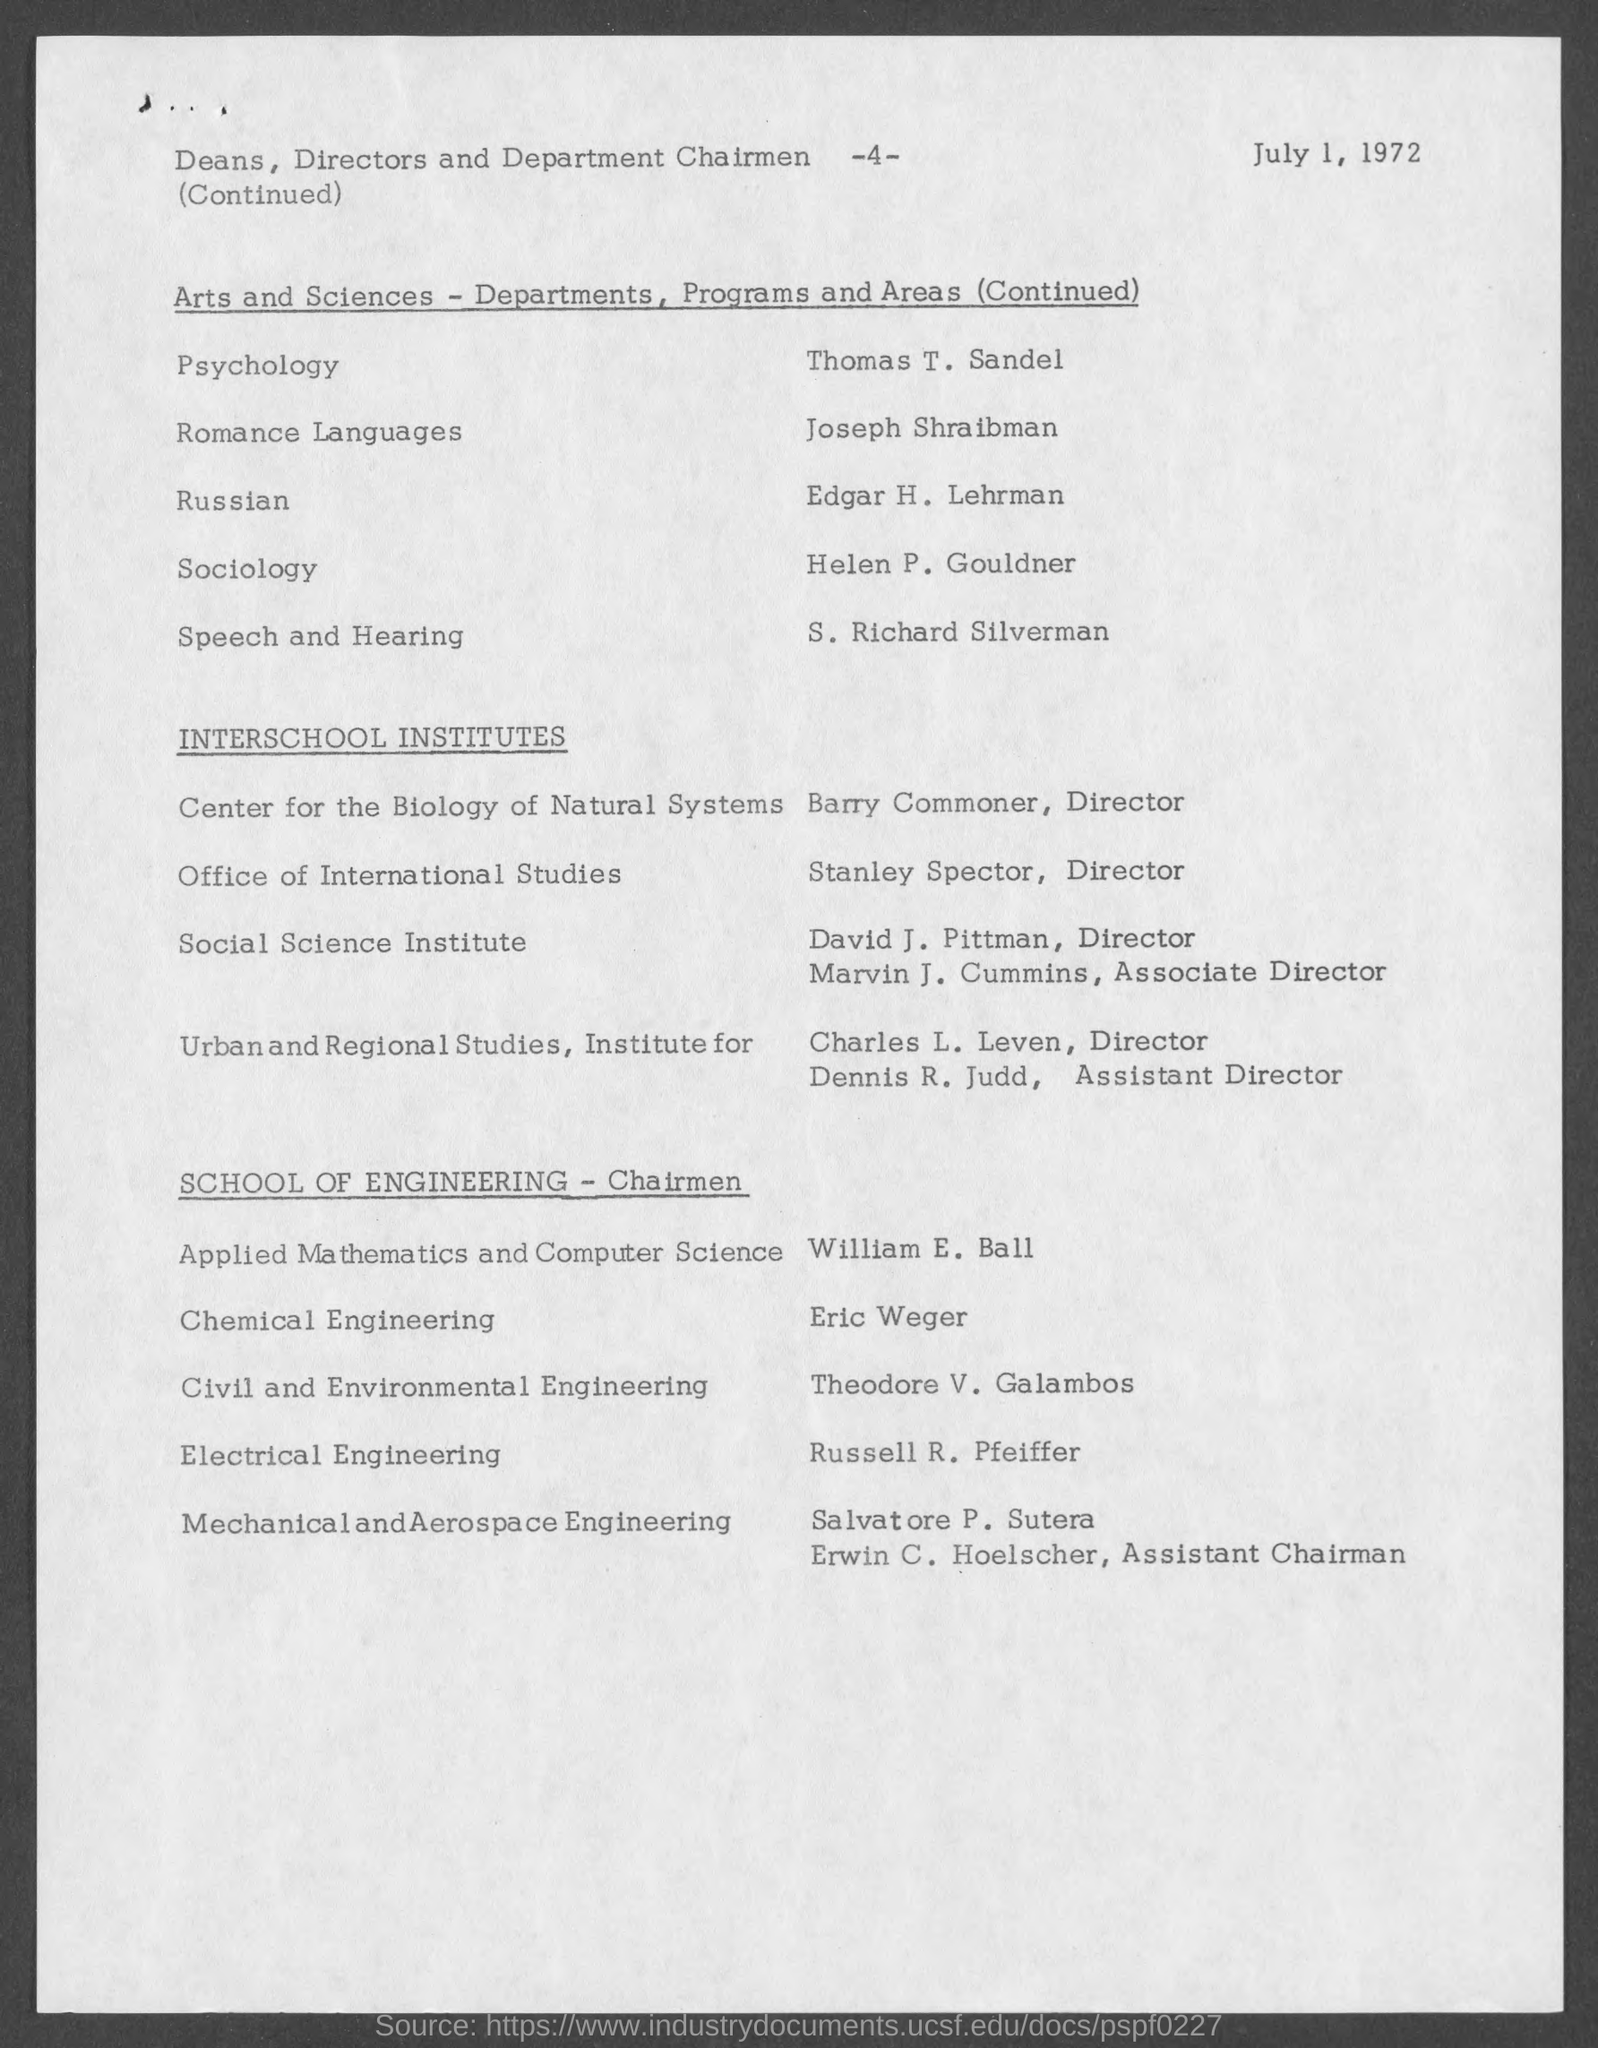What is the date mentioned in this document?
Your answer should be compact. July 1, 1972. Who is the Director of Center for the Biology of Natural Systems?
Provide a succinct answer. Barry Commoner. Who is the Director of Office of International Studies?
Ensure brevity in your answer.  Stanley Spector. 